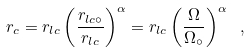<formula> <loc_0><loc_0><loc_500><loc_500>r _ { c } = r _ { l c } \left ( \frac { r _ { l c \circ } } { r _ { l c } } \right ) ^ { \alpha } = r _ { l c } \left ( \frac { \Omega } { \Omega _ { \circ } } \right ) ^ { \alpha } \ ,</formula> 